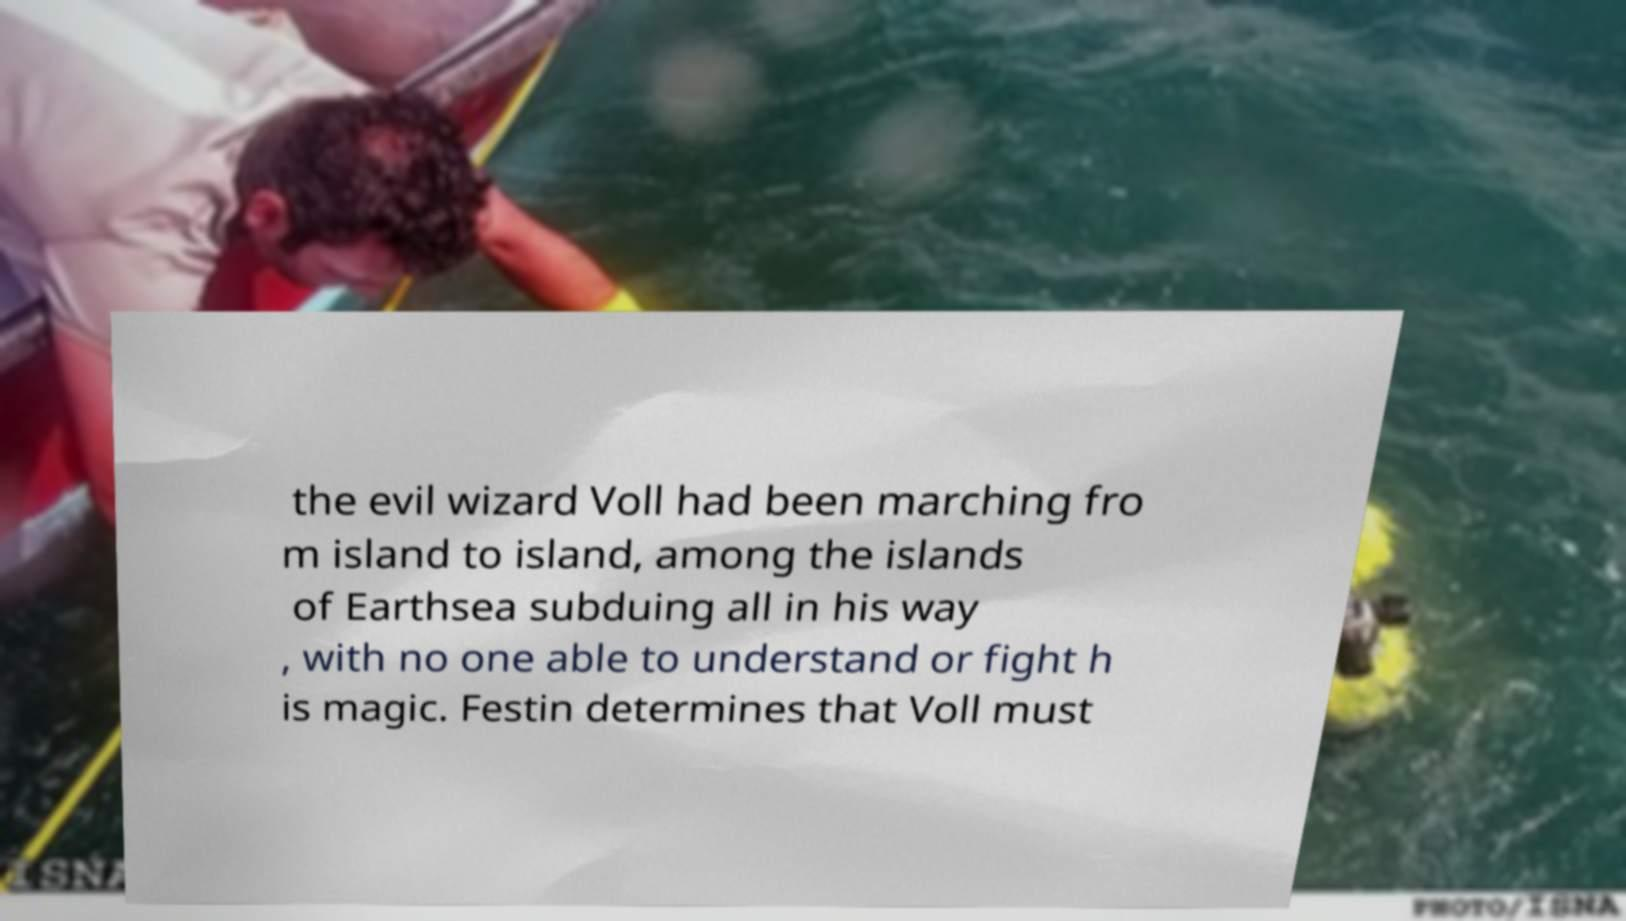Please read and relay the text visible in this image. What does it say? the evil wizard Voll had been marching fro m island to island, among the islands of Earthsea subduing all in his way , with no one able to understand or fight h is magic. Festin determines that Voll must 